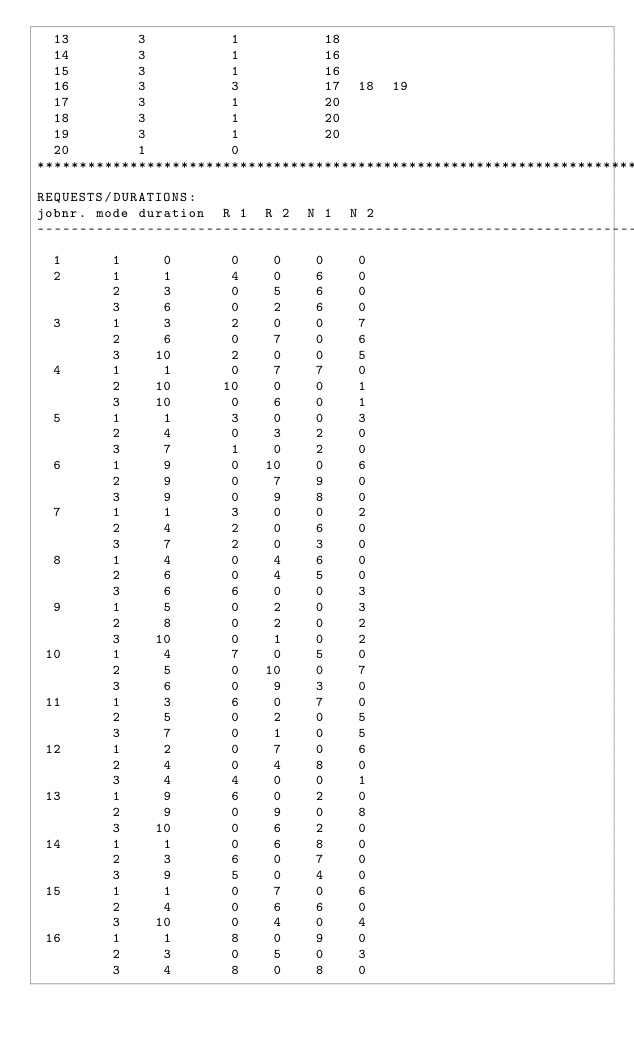Convert code to text. <code><loc_0><loc_0><loc_500><loc_500><_ObjectiveC_>  13        3          1          18
  14        3          1          16
  15        3          1          16
  16        3          3          17  18  19
  17        3          1          20
  18        3          1          20
  19        3          1          20
  20        1          0        
************************************************************************
REQUESTS/DURATIONS:
jobnr. mode duration  R 1  R 2  N 1  N 2
------------------------------------------------------------------------
  1      1     0       0    0    0    0
  2      1     1       4    0    6    0
         2     3       0    5    6    0
         3     6       0    2    6    0
  3      1     3       2    0    0    7
         2     6       0    7    0    6
         3    10       2    0    0    5
  4      1     1       0    7    7    0
         2    10      10    0    0    1
         3    10       0    6    0    1
  5      1     1       3    0    0    3
         2     4       0    3    2    0
         3     7       1    0    2    0
  6      1     9       0   10    0    6
         2     9       0    7    9    0
         3     9       0    9    8    0
  7      1     1       3    0    0    2
         2     4       2    0    6    0
         3     7       2    0    3    0
  8      1     4       0    4    6    0
         2     6       0    4    5    0
         3     6       6    0    0    3
  9      1     5       0    2    0    3
         2     8       0    2    0    2
         3    10       0    1    0    2
 10      1     4       7    0    5    0
         2     5       0   10    0    7
         3     6       0    9    3    0
 11      1     3       6    0    7    0
         2     5       0    2    0    5
         3     7       0    1    0    5
 12      1     2       0    7    0    6
         2     4       0    4    8    0
         3     4       4    0    0    1
 13      1     9       6    0    2    0
         2     9       0    9    0    8
         3    10       0    6    2    0
 14      1     1       0    6    8    0
         2     3       6    0    7    0
         3     9       5    0    4    0
 15      1     1       0    7    0    6
         2     4       0    6    6    0
         3    10       0    4    0    4
 16      1     1       8    0    9    0
         2     3       0    5    0    3
         3     4       8    0    8    0</code> 